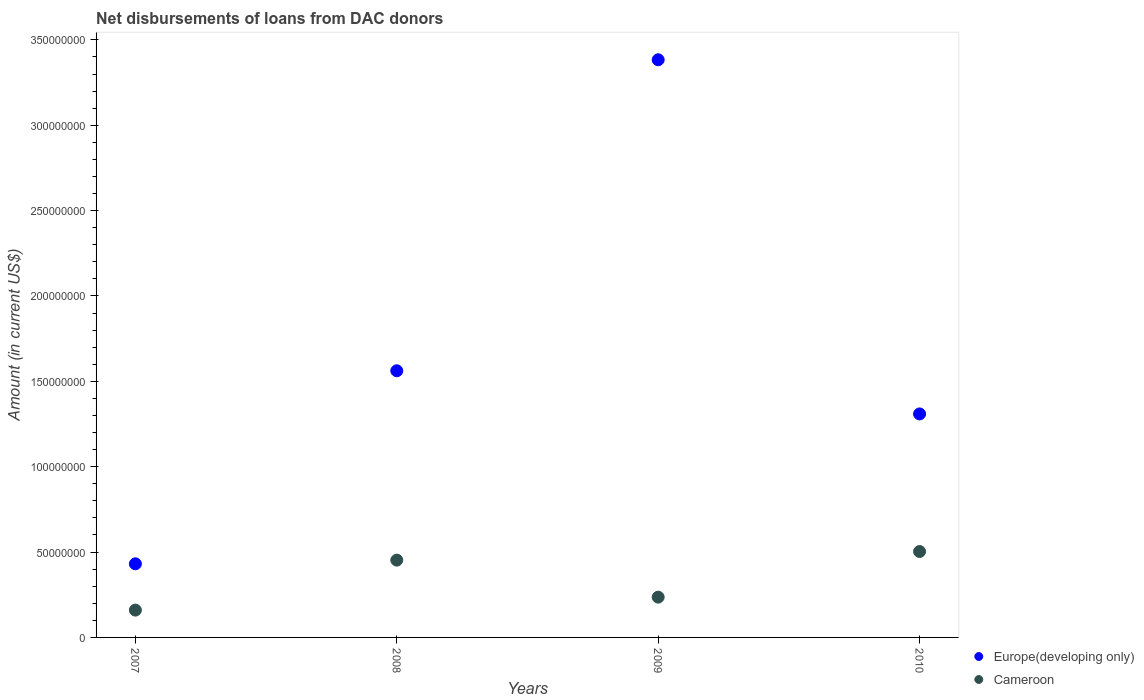Is the number of dotlines equal to the number of legend labels?
Your answer should be very brief. Yes. What is the amount of loans disbursed in Europe(developing only) in 2009?
Ensure brevity in your answer.  3.38e+08. Across all years, what is the maximum amount of loans disbursed in Cameroon?
Offer a very short reply. 5.03e+07. Across all years, what is the minimum amount of loans disbursed in Europe(developing only)?
Provide a succinct answer. 4.31e+07. What is the total amount of loans disbursed in Cameroon in the graph?
Give a very brief answer. 1.35e+08. What is the difference between the amount of loans disbursed in Europe(developing only) in 2009 and that in 2010?
Provide a succinct answer. 2.07e+08. What is the difference between the amount of loans disbursed in Cameroon in 2009 and the amount of loans disbursed in Europe(developing only) in 2007?
Your response must be concise. -1.95e+07. What is the average amount of loans disbursed in Europe(developing only) per year?
Offer a terse response. 1.67e+08. In the year 2009, what is the difference between the amount of loans disbursed in Cameroon and amount of loans disbursed in Europe(developing only)?
Offer a very short reply. -3.15e+08. What is the ratio of the amount of loans disbursed in Cameroon in 2007 to that in 2009?
Your response must be concise. 0.68. Is the difference between the amount of loans disbursed in Cameroon in 2008 and 2010 greater than the difference between the amount of loans disbursed in Europe(developing only) in 2008 and 2010?
Offer a terse response. No. What is the difference between the highest and the second highest amount of loans disbursed in Cameroon?
Give a very brief answer. 5.04e+06. What is the difference between the highest and the lowest amount of loans disbursed in Europe(developing only)?
Your response must be concise. 2.95e+08. In how many years, is the amount of loans disbursed in Cameroon greater than the average amount of loans disbursed in Cameroon taken over all years?
Your response must be concise. 2. Is the amount of loans disbursed in Europe(developing only) strictly less than the amount of loans disbursed in Cameroon over the years?
Offer a terse response. No. How many years are there in the graph?
Your answer should be very brief. 4. Where does the legend appear in the graph?
Your answer should be very brief. Bottom right. How many legend labels are there?
Offer a terse response. 2. How are the legend labels stacked?
Your response must be concise. Vertical. What is the title of the graph?
Your response must be concise. Net disbursements of loans from DAC donors. Does "Congo (Republic)" appear as one of the legend labels in the graph?
Your answer should be compact. No. What is the label or title of the Y-axis?
Make the answer very short. Amount (in current US$). What is the Amount (in current US$) of Europe(developing only) in 2007?
Your answer should be very brief. 4.31e+07. What is the Amount (in current US$) of Cameroon in 2007?
Your answer should be compact. 1.60e+07. What is the Amount (in current US$) of Europe(developing only) in 2008?
Provide a succinct answer. 1.56e+08. What is the Amount (in current US$) in Cameroon in 2008?
Make the answer very short. 4.53e+07. What is the Amount (in current US$) of Europe(developing only) in 2009?
Provide a succinct answer. 3.38e+08. What is the Amount (in current US$) of Cameroon in 2009?
Provide a succinct answer. 2.36e+07. What is the Amount (in current US$) of Europe(developing only) in 2010?
Keep it short and to the point. 1.31e+08. What is the Amount (in current US$) in Cameroon in 2010?
Offer a very short reply. 5.03e+07. Across all years, what is the maximum Amount (in current US$) of Europe(developing only)?
Your answer should be compact. 3.38e+08. Across all years, what is the maximum Amount (in current US$) in Cameroon?
Ensure brevity in your answer.  5.03e+07. Across all years, what is the minimum Amount (in current US$) in Europe(developing only)?
Offer a very short reply. 4.31e+07. Across all years, what is the minimum Amount (in current US$) in Cameroon?
Your response must be concise. 1.60e+07. What is the total Amount (in current US$) in Europe(developing only) in the graph?
Keep it short and to the point. 6.69e+08. What is the total Amount (in current US$) in Cameroon in the graph?
Make the answer very short. 1.35e+08. What is the difference between the Amount (in current US$) in Europe(developing only) in 2007 and that in 2008?
Your answer should be compact. -1.13e+08. What is the difference between the Amount (in current US$) in Cameroon in 2007 and that in 2008?
Ensure brevity in your answer.  -2.93e+07. What is the difference between the Amount (in current US$) of Europe(developing only) in 2007 and that in 2009?
Your answer should be compact. -2.95e+08. What is the difference between the Amount (in current US$) in Cameroon in 2007 and that in 2009?
Keep it short and to the point. -7.59e+06. What is the difference between the Amount (in current US$) of Europe(developing only) in 2007 and that in 2010?
Your response must be concise. -8.78e+07. What is the difference between the Amount (in current US$) of Cameroon in 2007 and that in 2010?
Make the answer very short. -3.43e+07. What is the difference between the Amount (in current US$) in Europe(developing only) in 2008 and that in 2009?
Offer a very short reply. -1.82e+08. What is the difference between the Amount (in current US$) of Cameroon in 2008 and that in 2009?
Provide a succinct answer. 2.17e+07. What is the difference between the Amount (in current US$) of Europe(developing only) in 2008 and that in 2010?
Provide a succinct answer. 2.53e+07. What is the difference between the Amount (in current US$) of Cameroon in 2008 and that in 2010?
Provide a short and direct response. -5.04e+06. What is the difference between the Amount (in current US$) in Europe(developing only) in 2009 and that in 2010?
Offer a terse response. 2.07e+08. What is the difference between the Amount (in current US$) of Cameroon in 2009 and that in 2010?
Your answer should be very brief. -2.67e+07. What is the difference between the Amount (in current US$) of Europe(developing only) in 2007 and the Amount (in current US$) of Cameroon in 2008?
Your response must be concise. -2.17e+06. What is the difference between the Amount (in current US$) of Europe(developing only) in 2007 and the Amount (in current US$) of Cameroon in 2009?
Your answer should be very brief. 1.95e+07. What is the difference between the Amount (in current US$) in Europe(developing only) in 2007 and the Amount (in current US$) in Cameroon in 2010?
Ensure brevity in your answer.  -7.21e+06. What is the difference between the Amount (in current US$) in Europe(developing only) in 2008 and the Amount (in current US$) in Cameroon in 2009?
Ensure brevity in your answer.  1.33e+08. What is the difference between the Amount (in current US$) in Europe(developing only) in 2008 and the Amount (in current US$) in Cameroon in 2010?
Your response must be concise. 1.06e+08. What is the difference between the Amount (in current US$) of Europe(developing only) in 2009 and the Amount (in current US$) of Cameroon in 2010?
Make the answer very short. 2.88e+08. What is the average Amount (in current US$) of Europe(developing only) per year?
Keep it short and to the point. 1.67e+08. What is the average Amount (in current US$) of Cameroon per year?
Ensure brevity in your answer.  3.38e+07. In the year 2007, what is the difference between the Amount (in current US$) of Europe(developing only) and Amount (in current US$) of Cameroon?
Ensure brevity in your answer.  2.71e+07. In the year 2008, what is the difference between the Amount (in current US$) in Europe(developing only) and Amount (in current US$) in Cameroon?
Make the answer very short. 1.11e+08. In the year 2009, what is the difference between the Amount (in current US$) in Europe(developing only) and Amount (in current US$) in Cameroon?
Give a very brief answer. 3.15e+08. In the year 2010, what is the difference between the Amount (in current US$) of Europe(developing only) and Amount (in current US$) of Cameroon?
Give a very brief answer. 8.06e+07. What is the ratio of the Amount (in current US$) in Europe(developing only) in 2007 to that in 2008?
Your response must be concise. 0.28. What is the ratio of the Amount (in current US$) of Cameroon in 2007 to that in 2008?
Give a very brief answer. 0.35. What is the ratio of the Amount (in current US$) in Europe(developing only) in 2007 to that in 2009?
Ensure brevity in your answer.  0.13. What is the ratio of the Amount (in current US$) in Cameroon in 2007 to that in 2009?
Your response must be concise. 0.68. What is the ratio of the Amount (in current US$) of Europe(developing only) in 2007 to that in 2010?
Offer a very short reply. 0.33. What is the ratio of the Amount (in current US$) of Cameroon in 2007 to that in 2010?
Offer a very short reply. 0.32. What is the ratio of the Amount (in current US$) in Europe(developing only) in 2008 to that in 2009?
Give a very brief answer. 0.46. What is the ratio of the Amount (in current US$) of Cameroon in 2008 to that in 2009?
Make the answer very short. 1.92. What is the ratio of the Amount (in current US$) in Europe(developing only) in 2008 to that in 2010?
Make the answer very short. 1.19. What is the ratio of the Amount (in current US$) of Cameroon in 2008 to that in 2010?
Ensure brevity in your answer.  0.9. What is the ratio of the Amount (in current US$) in Europe(developing only) in 2009 to that in 2010?
Your answer should be compact. 2.58. What is the ratio of the Amount (in current US$) of Cameroon in 2009 to that in 2010?
Offer a very short reply. 0.47. What is the difference between the highest and the second highest Amount (in current US$) of Europe(developing only)?
Your answer should be very brief. 1.82e+08. What is the difference between the highest and the second highest Amount (in current US$) in Cameroon?
Your response must be concise. 5.04e+06. What is the difference between the highest and the lowest Amount (in current US$) in Europe(developing only)?
Keep it short and to the point. 2.95e+08. What is the difference between the highest and the lowest Amount (in current US$) of Cameroon?
Give a very brief answer. 3.43e+07. 